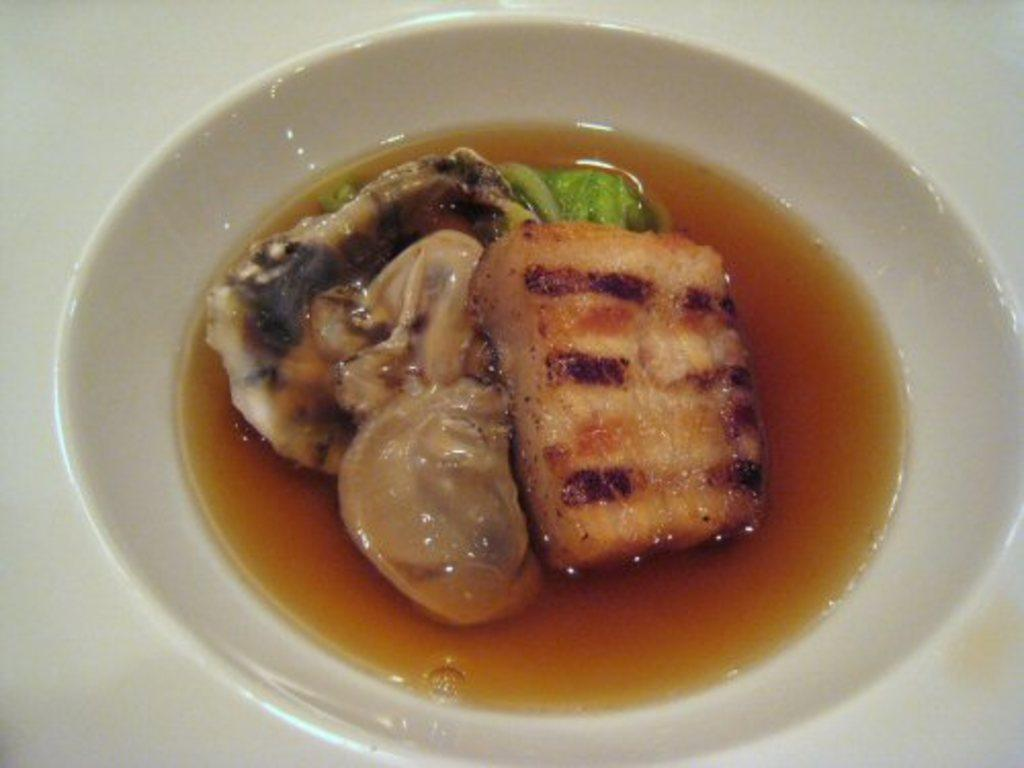What is on the plate in the image? There is food in the plate in the image. What color is the background of the image? The background of the image is white. How many tickets are visible in the image? There are no tickets present in the image. What type of straw is used to stir the food in the image? There is no straw present in the image, and the food does not require stirring. 